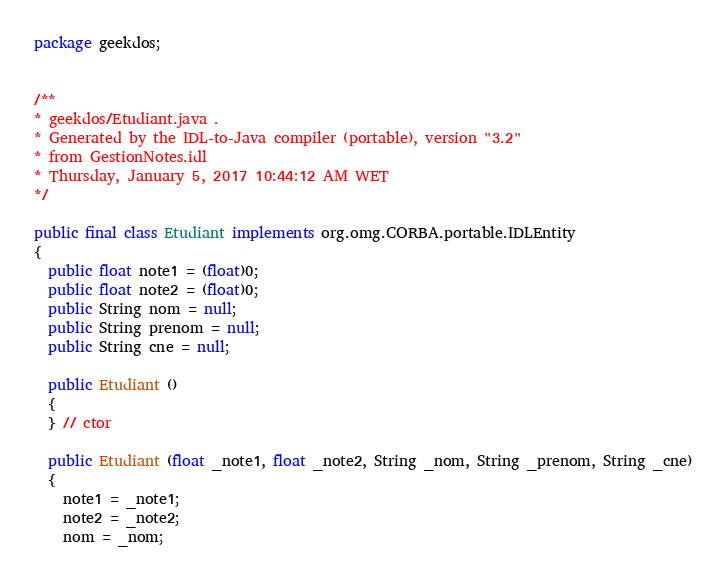<code> <loc_0><loc_0><loc_500><loc_500><_Java_>package geekdos;


/**
* geekdos/Etudiant.java .
* Generated by the IDL-to-Java compiler (portable), version "3.2"
* from GestionNotes.idl
* Thursday, January 5, 2017 10:44:12 AM WET
*/

public final class Etudiant implements org.omg.CORBA.portable.IDLEntity
{
  public float note1 = (float)0;
  public float note2 = (float)0;
  public String nom = null;
  public String prenom = null;
  public String cne = null;

  public Etudiant ()
  {
  } // ctor

  public Etudiant (float _note1, float _note2, String _nom, String _prenom, String _cne)
  {
    note1 = _note1;
    note2 = _note2;
    nom = _nom;</code> 